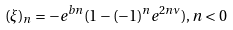Convert formula to latex. <formula><loc_0><loc_0><loc_500><loc_500>( \xi ) _ { n } = - e ^ { b n } ( 1 - ( - 1 ) ^ { n } e ^ { 2 n \nu } ) , n < 0</formula> 